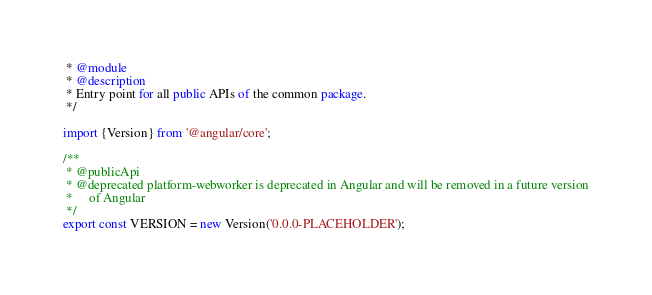<code> <loc_0><loc_0><loc_500><loc_500><_TypeScript_> * @module
 * @description
 * Entry point for all public APIs of the common package.
 */

import {Version} from '@angular/core';

/**
 * @publicApi
 * @deprecated platform-webworker is deprecated in Angular and will be removed in a future version
 *     of Angular
 */
export const VERSION = new Version('0.0.0-PLACEHOLDER');
</code> 